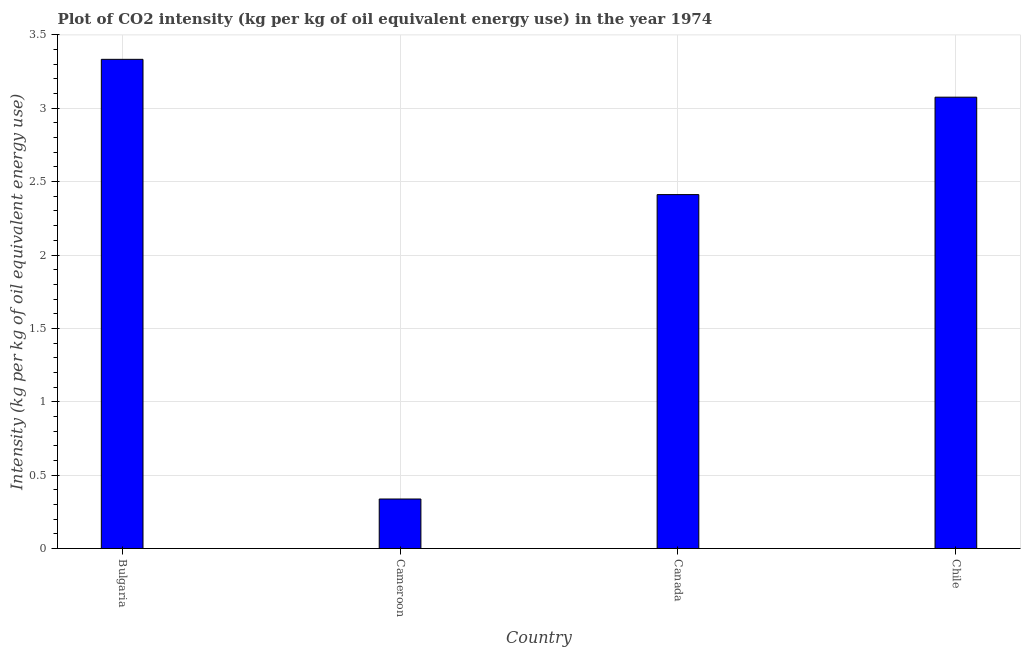Does the graph contain any zero values?
Your answer should be very brief. No. What is the title of the graph?
Your answer should be very brief. Plot of CO2 intensity (kg per kg of oil equivalent energy use) in the year 1974. What is the label or title of the Y-axis?
Provide a succinct answer. Intensity (kg per kg of oil equivalent energy use). What is the co2 intensity in Cameroon?
Provide a short and direct response. 0.34. Across all countries, what is the maximum co2 intensity?
Offer a very short reply. 3.33. Across all countries, what is the minimum co2 intensity?
Offer a very short reply. 0.34. In which country was the co2 intensity minimum?
Provide a short and direct response. Cameroon. What is the sum of the co2 intensity?
Keep it short and to the point. 9.16. What is the difference between the co2 intensity in Cameroon and Canada?
Your response must be concise. -2.07. What is the average co2 intensity per country?
Your response must be concise. 2.29. What is the median co2 intensity?
Provide a short and direct response. 2.74. What is the ratio of the co2 intensity in Bulgaria to that in Cameroon?
Offer a very short reply. 9.89. Is the co2 intensity in Canada less than that in Chile?
Offer a very short reply. Yes. What is the difference between the highest and the second highest co2 intensity?
Your answer should be very brief. 0.26. Is the sum of the co2 intensity in Bulgaria and Cameroon greater than the maximum co2 intensity across all countries?
Provide a short and direct response. Yes. What is the difference between the highest and the lowest co2 intensity?
Your answer should be very brief. 3. In how many countries, is the co2 intensity greater than the average co2 intensity taken over all countries?
Provide a succinct answer. 3. Are all the bars in the graph horizontal?
Your answer should be very brief. No. Are the values on the major ticks of Y-axis written in scientific E-notation?
Ensure brevity in your answer.  No. What is the Intensity (kg per kg of oil equivalent energy use) of Bulgaria?
Provide a short and direct response. 3.33. What is the Intensity (kg per kg of oil equivalent energy use) of Cameroon?
Your answer should be very brief. 0.34. What is the Intensity (kg per kg of oil equivalent energy use) in Canada?
Your answer should be very brief. 2.41. What is the Intensity (kg per kg of oil equivalent energy use) of Chile?
Keep it short and to the point. 3.08. What is the difference between the Intensity (kg per kg of oil equivalent energy use) in Bulgaria and Cameroon?
Your answer should be compact. 3. What is the difference between the Intensity (kg per kg of oil equivalent energy use) in Bulgaria and Canada?
Ensure brevity in your answer.  0.92. What is the difference between the Intensity (kg per kg of oil equivalent energy use) in Bulgaria and Chile?
Ensure brevity in your answer.  0.26. What is the difference between the Intensity (kg per kg of oil equivalent energy use) in Cameroon and Canada?
Your answer should be very brief. -2.07. What is the difference between the Intensity (kg per kg of oil equivalent energy use) in Cameroon and Chile?
Offer a terse response. -2.74. What is the difference between the Intensity (kg per kg of oil equivalent energy use) in Canada and Chile?
Your answer should be compact. -0.66. What is the ratio of the Intensity (kg per kg of oil equivalent energy use) in Bulgaria to that in Cameroon?
Offer a terse response. 9.89. What is the ratio of the Intensity (kg per kg of oil equivalent energy use) in Bulgaria to that in Canada?
Your response must be concise. 1.38. What is the ratio of the Intensity (kg per kg of oil equivalent energy use) in Bulgaria to that in Chile?
Your answer should be compact. 1.08. What is the ratio of the Intensity (kg per kg of oil equivalent energy use) in Cameroon to that in Canada?
Provide a succinct answer. 0.14. What is the ratio of the Intensity (kg per kg of oil equivalent energy use) in Cameroon to that in Chile?
Your answer should be compact. 0.11. What is the ratio of the Intensity (kg per kg of oil equivalent energy use) in Canada to that in Chile?
Make the answer very short. 0.78. 